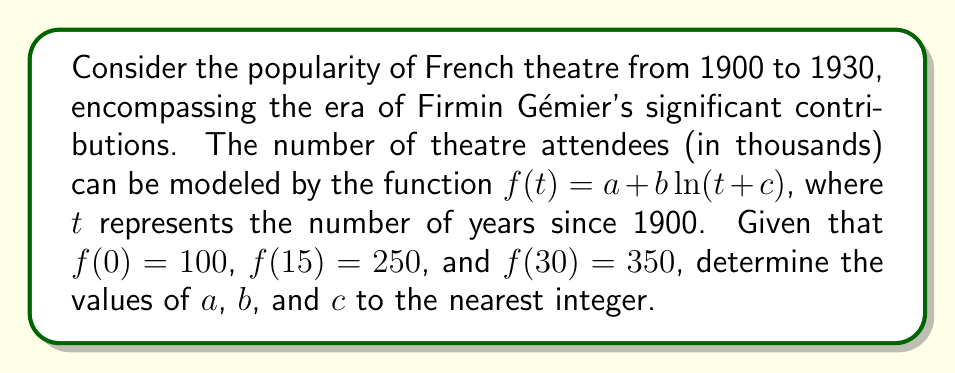What is the answer to this math problem? 1) We have three equations based on the given information:

   $a + b\ln(c) = 100$
   $a + b\ln(15+c) = 250$
   $a + b\ln(30+c) = 350$

2) Subtracting the first equation from the second and third:

   $b[\ln(15+c) - \ln(c)] = 150$
   $b[\ln(30+c) - \ln(c)] = 250$

3) Dividing these equations:

   $\frac{\ln(15+c) - \ln(c)}{\ln(30+c) - \ln(c)} = \frac{3}{5}$

4) This can be simplified to:

   $\frac{\ln(\frac{15+c}{c})}{\ln(\frac{30+c}{c})} = \frac{3}{5}$

5) Let $x = \frac{c}{15}$. Then the equation becomes:

   $\frac{\ln(1+\frac{1}{x})}{\ln(1+\frac{2}{x})} = \frac{3}{5}$

6) This equation can be solved numerically to get $x \approx 0.5$, so $c \approx 7.5$

7) Substituting back into the equations from step 2:

   $b \cdot \ln(\frac{22.5}{7.5}) = 150$
   $b \cdot \ln(3) = 150$
   $b \approx 136.5$

8) From the first equation in step 1:

   $a + 136.5 \cdot \ln(7.5) = 100$
   $a \approx -177$

9) Rounding to the nearest integer:

   $a = -177$, $b = 137$, $c = 8$
Answer: $a = -177$, $b = 137$, $c = 8$ 